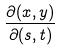Convert formula to latex. <formula><loc_0><loc_0><loc_500><loc_500>\frac { \partial ( x , y ) } { \partial ( s , t ) }</formula> 